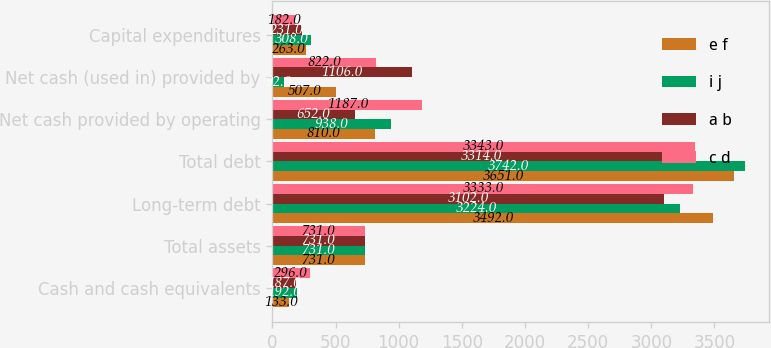Convert chart. <chart><loc_0><loc_0><loc_500><loc_500><stacked_bar_chart><ecel><fcel>Cash and cash equivalents<fcel>Total assets<fcel>Long-term debt<fcel>Total debt<fcel>Net cash provided by operating<fcel>Net cash (used in) provided by<fcel>Capital expenditures<nl><fcel>e f<fcel>133<fcel>731<fcel>3492<fcel>3651<fcel>810<fcel>507<fcel>263<nl><fcel>i j<fcel>192<fcel>731<fcel>3224<fcel>3742<fcel>938<fcel>92<fcel>308<nl><fcel>a b<fcel>187<fcel>731<fcel>3102<fcel>3314<fcel>652<fcel>1106<fcel>231<nl><fcel>c d<fcel>296<fcel>731<fcel>3333<fcel>3343<fcel>1187<fcel>822<fcel>182<nl></chart> 